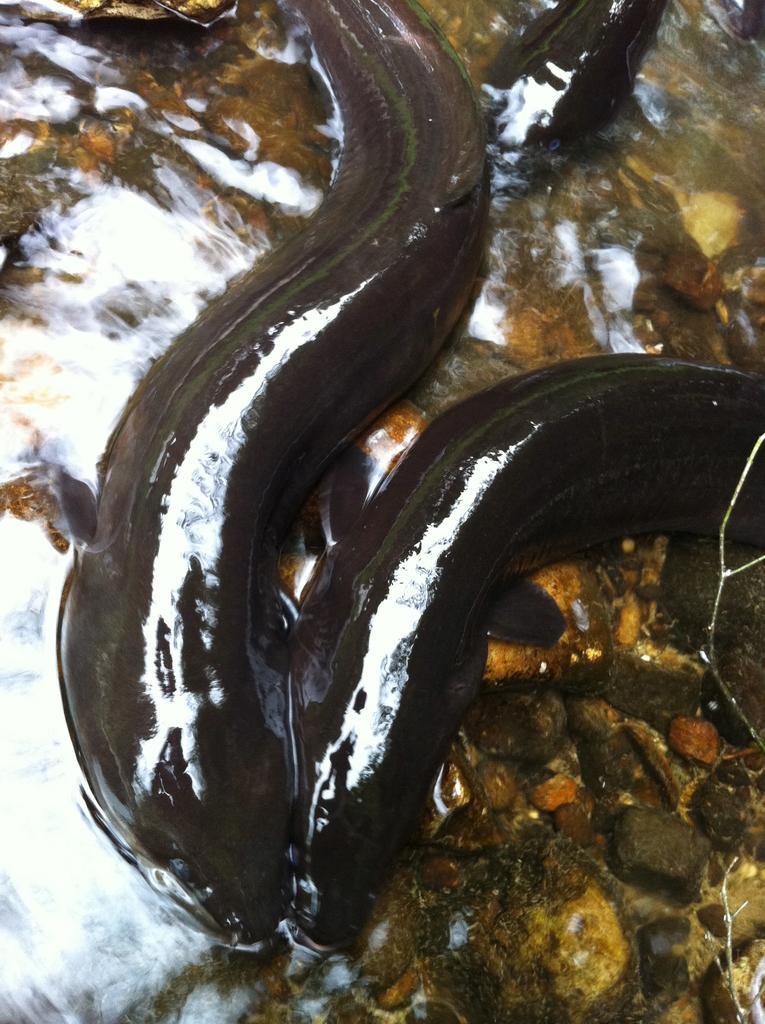Can you describe this image briefly? In this picture we can see fishes here, at the bottom there is water, we can see some stones here. 